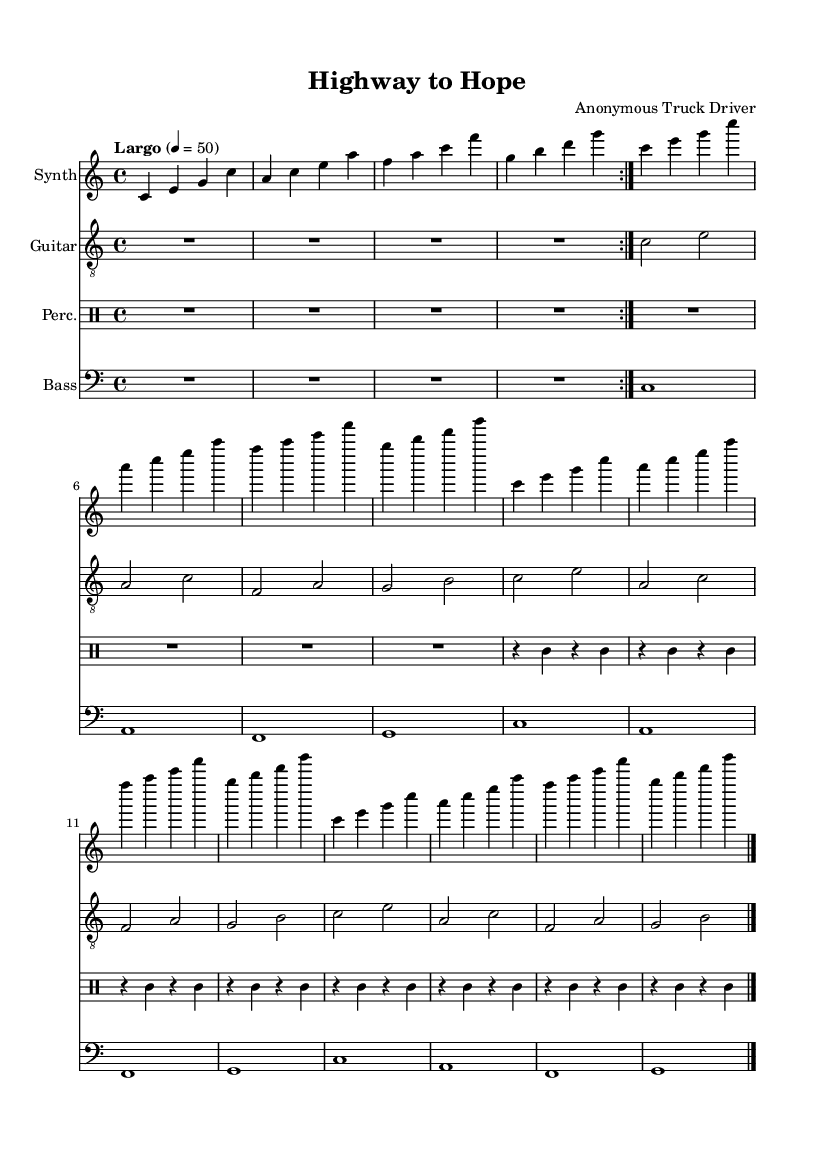What is the key signature of this music? The key signature indicated at the beginning of the score is C major, which contains no sharps or flats.
Answer: C major What is the time signature of this piece? The time signature, shown at the beginning as 4/4, means there are four beats per measure, and the quarter note gets one beat.
Answer: 4/4 What is the tempo marking? The tempo marking is indicated as "Largo" with a metronome mark of 50, suggesting a slow and broad tempo.
Answer: Largo 4 = 50 How many measures are in the synth section? The synth section starts with a repeat and contains three distinct sections: two repeated measures and three unfolded measures. This totals to 8 measures before it ends with a bar line.
Answer: 8 What instruments are used in this score? The score lists four instruments: Synth, Guitar, Percussion, and Bass, each represented on its own staff.
Answer: Synth, Guitar, Percussion, Bass How many times is the motif in the percussion repeated? The percussion section has a repeated motif, shown as four rhythmic patterns that are repeated twice. That totals to 8 measures given the rest period at the beginning.
Answer: 2 What is the structure of the guitar part? The guitar part is structured with rests and then unfolds into three parts, with each part including two measures, resulting in a total of 6 measures after repetition.
Answer: 6 